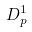Convert formula to latex. <formula><loc_0><loc_0><loc_500><loc_500>D _ { p } ^ { 1 }</formula> 